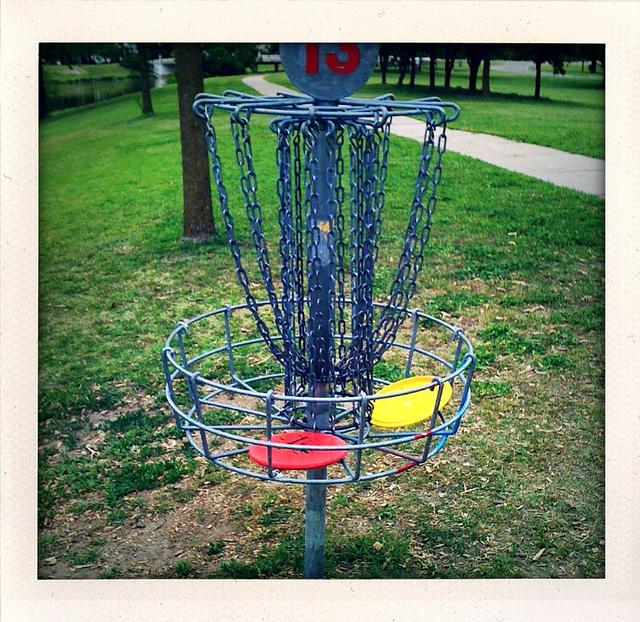Is this a play park?
Write a very short answer. Yes. What sport is this?
Quick response, please. Disc golf. What color are the chains?
Keep it brief. Blue. 